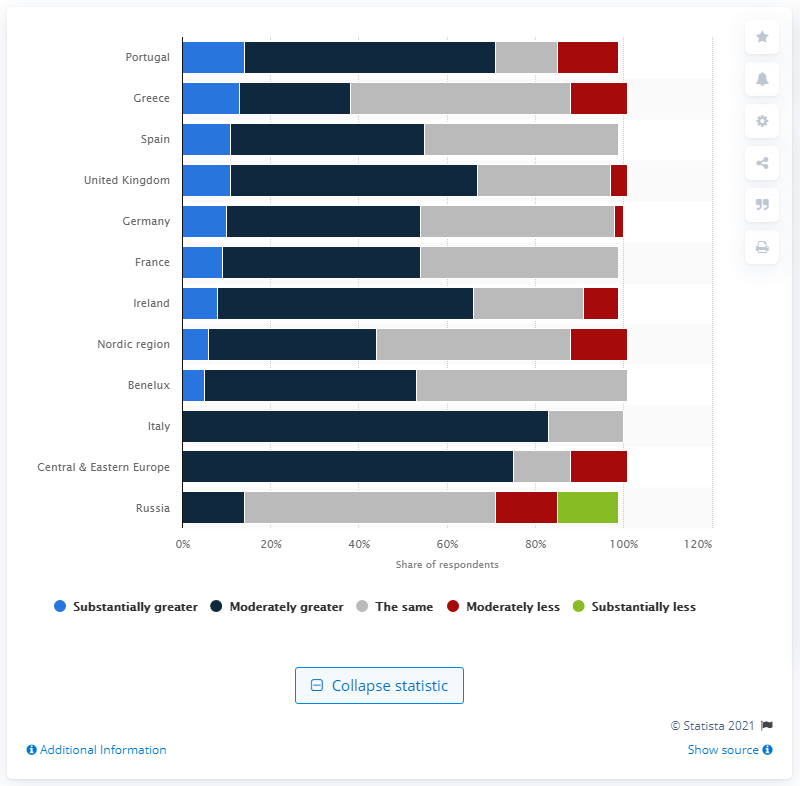Point out several critical features in this image. According to the survey, a substantial portion of Russians, around 10%, expected the availability of debt to be substantially less in the future. A survey of experts revealed that a majority, 38%, believed that the availability of debt would be greater in the Nordic region. 